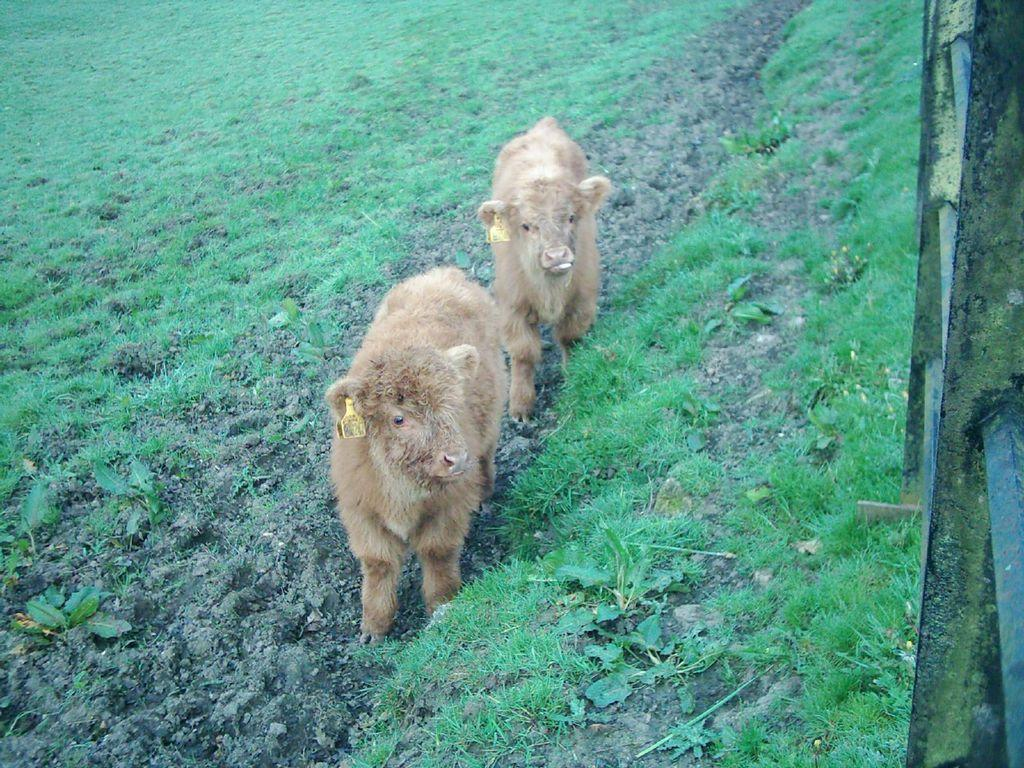What type of living organisms can be seen standing on the ground in the image? There are animals standing on the ground in the image. What type of vegetation can be seen in the background of the image? There is grass visible in the background of the image. What type of yoke can be seen being used by the animals in the image? There is no yoke present in the image, and the animals are not using any such equipment. 